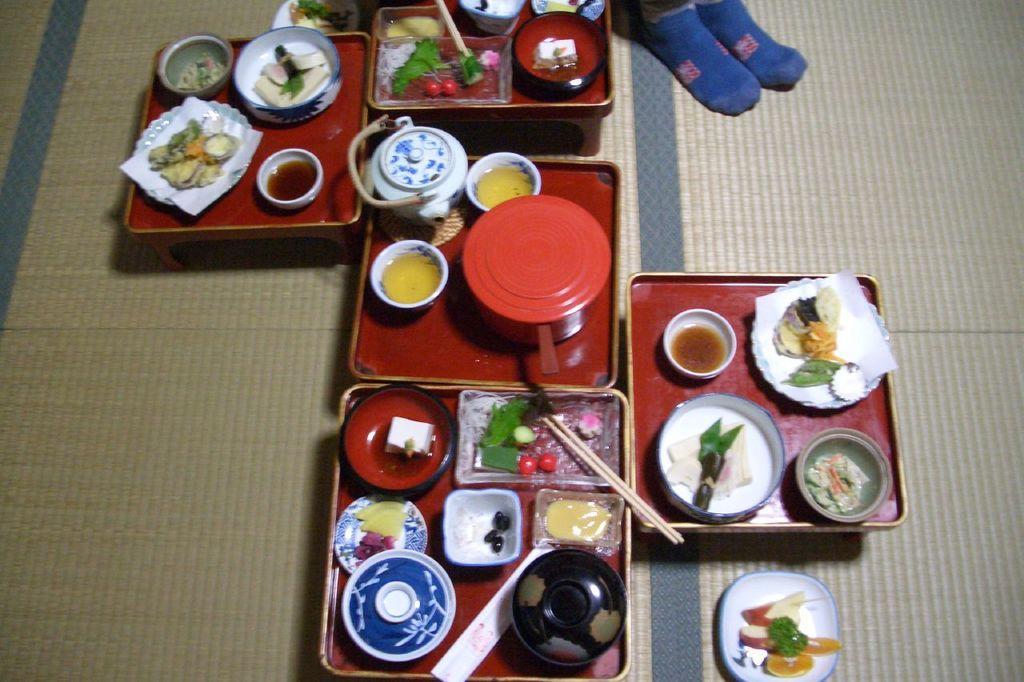In one or two sentences, can you explain what this image depicts? In this i can see on the floor there are the group of plates kept on the floor and on the plate there are the bowls and there are the some trays and there are some food items kept on the bowls 